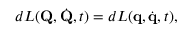Convert formula to latex. <formula><loc_0><loc_0><loc_500><loc_500>d L ( Q , { \dot { Q } } , t ) = d L ( q , { \dot { q } } , t ) ,</formula> 